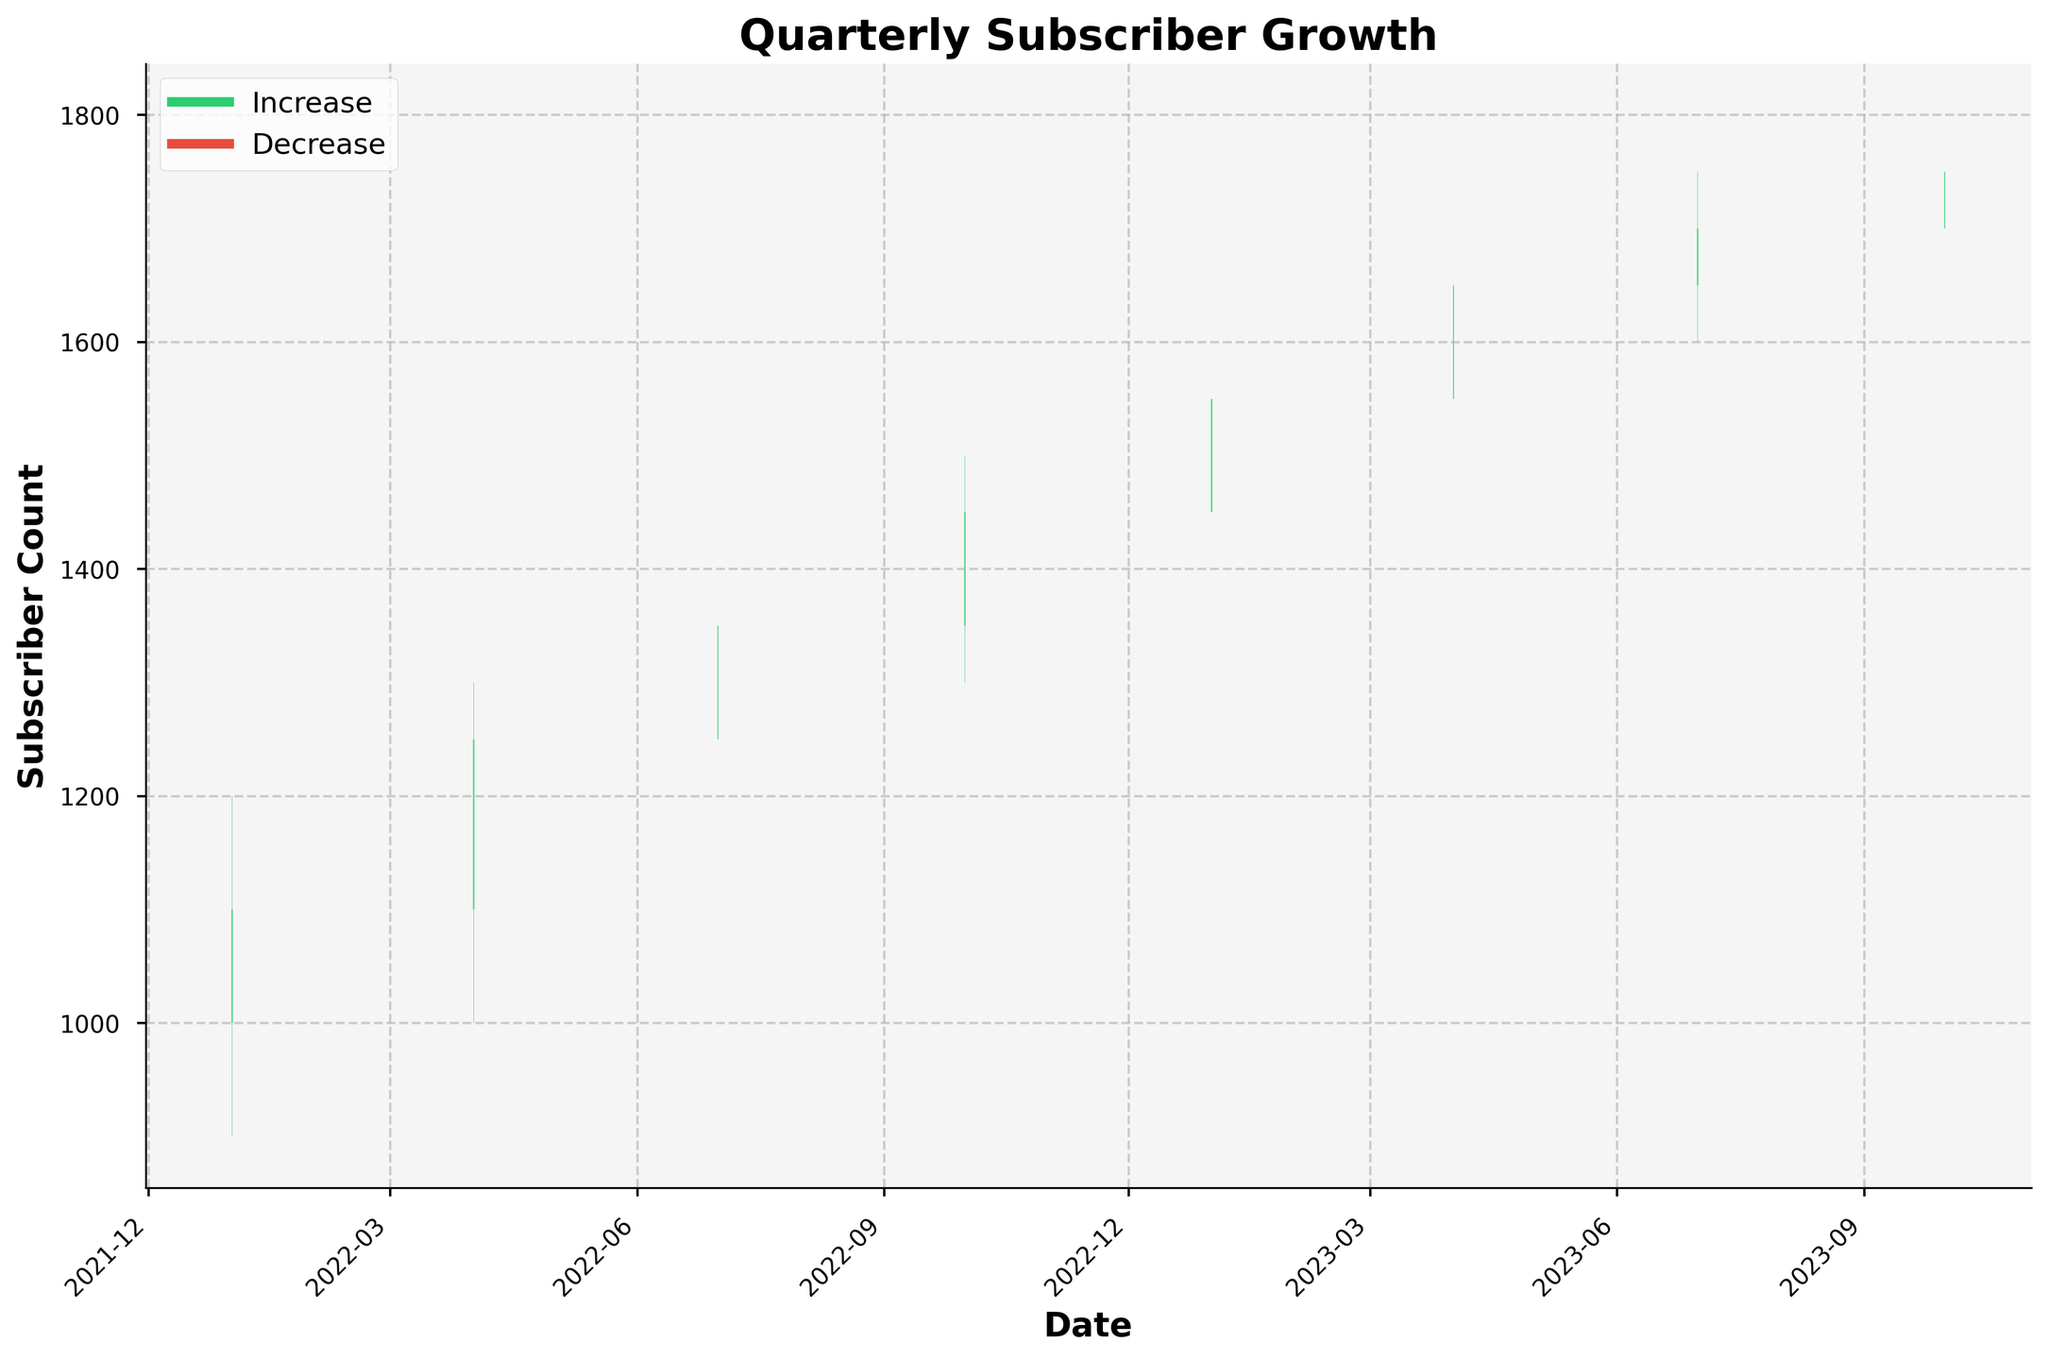What is the title of the plot? The title of the plot is prominently displayed at the top and reads "Quarterly Subscriber Growth".
Answer: Quarterly Subscriber Growth What do the green bars represent? In the legend, the green bars are labeled as "Increase", indicating periods where the closing subscriber count was higher than the opening count.
Answer: Increase How many quarters show an increase in subscriber count? To find this, count the green bars in the plot. The data shows green bars for 7 out of 8 quarters.
Answer: 7 quarters What was the highest peak for subscribers in this plot? The highest peak in the plot is represented by the top edge of the tallest bar, which is labeled at 1800 subscribers in October 2023.
Answer: 1800 subscribers Which quarter had the lowest low for subscribers? The lowest point in the plot corresponds to the bottom of the lowest bar, which is at 900 subscribers in January 2022.
Answer: January 2022 In which quarter did subscribers remain the same from open to close? This can be seen where the open and close prices are the same. There are no such quarters in this dataset, as all quarters show either an increase or decrease.
Answer: None What is the overall trend in subscriber growth from January 2022 to October 2023? The trend can be identified by observing the direction and length of bars over time. Overall, the subscriber count increased from 1000 to 1750.
Answer: Increasing trend What is the average opening subscriber count across all quarters? Add all the opening counts and divide by the number of quarters: (1000 + 1100 + 1250 + 1350 + 1450 + 1550 + 1650 + 1700) / 8 = 1306.25.
Answer: 1306.25 Which quarter had the largest fluctuation from high to low in subscriber count? The largest gap between the high and low can be seen where the vertical range of the bar is the greatest. April 2022 shows the largest fluctuation with a range of 300 (1300-1000).
Answer: April 2022 How can you identify a quarter with a subscriber decrease versus an increase? In the plot, a decrease is represented by a red bar, while an increase is represented by a green bar.
Answer: Red bar vs. Green bar 